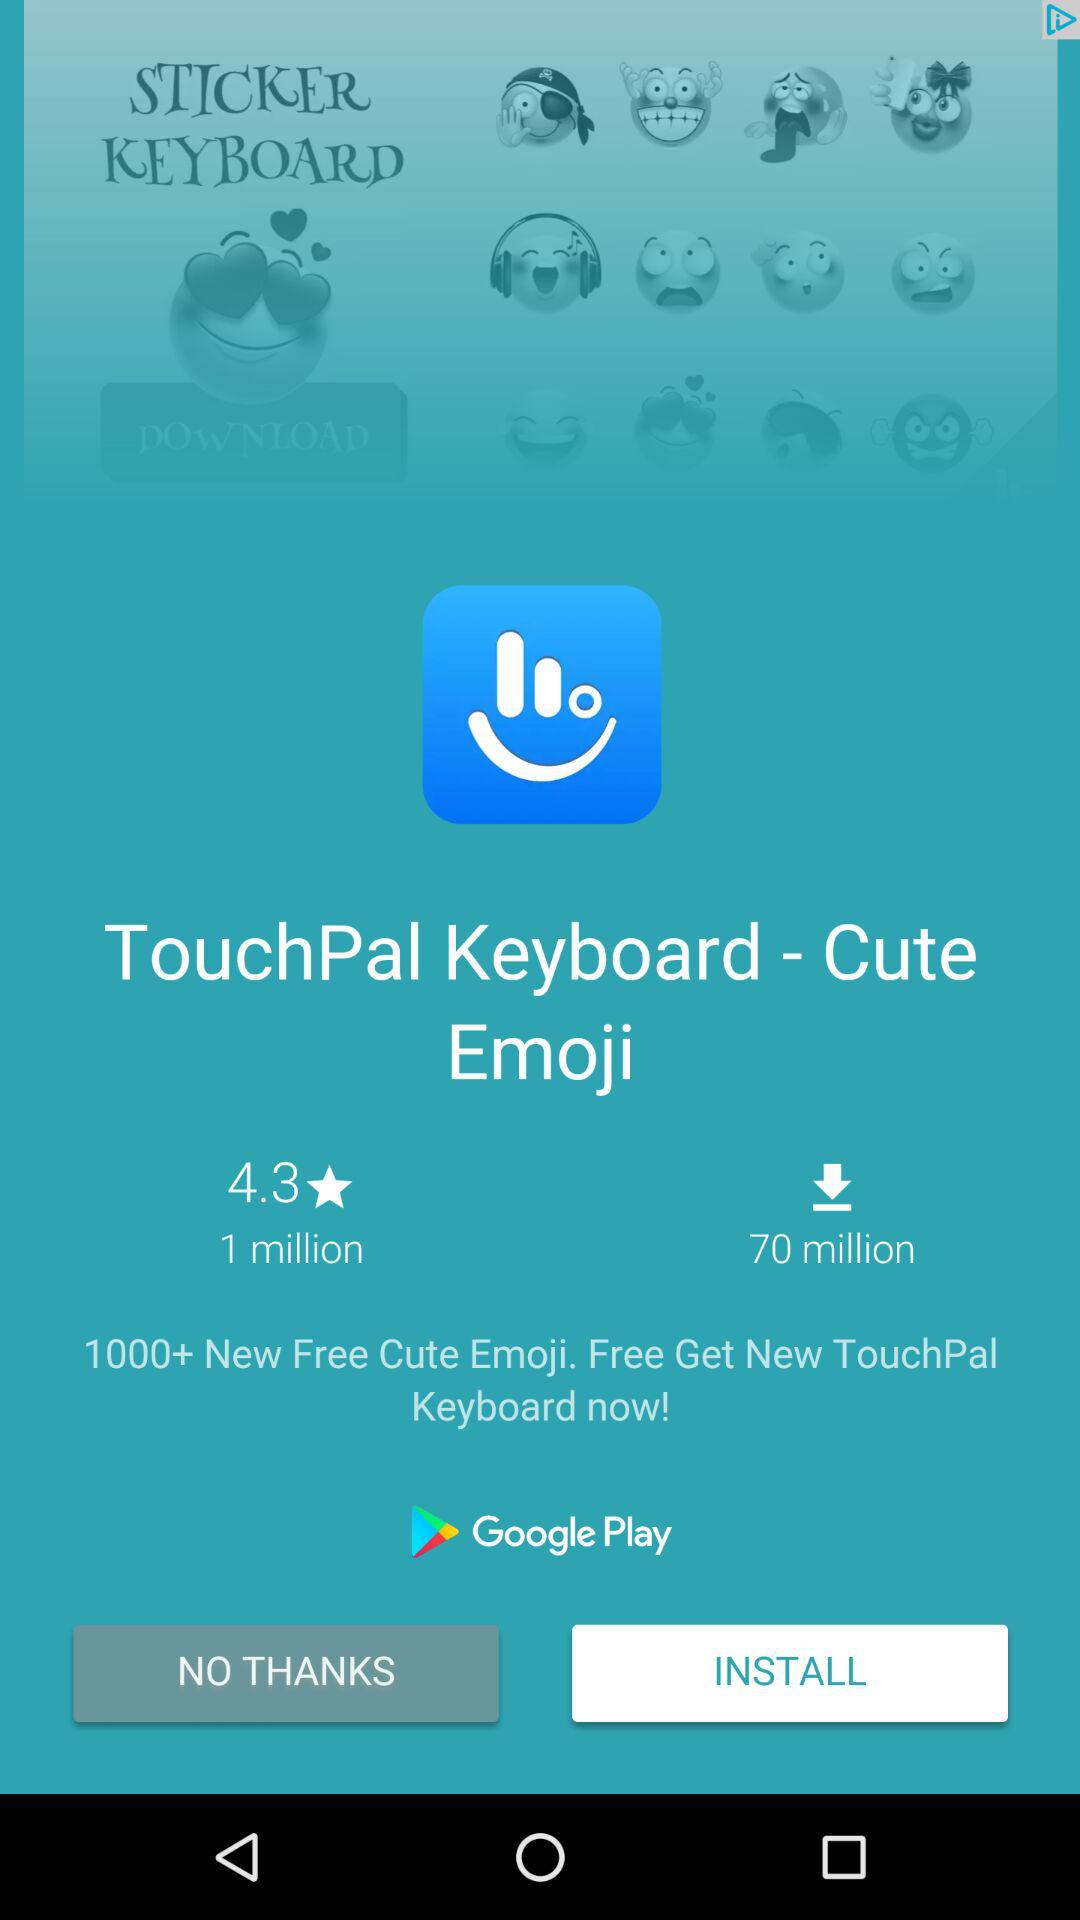How many people have downloaded the application? The number of people who have downloaded the application is 70 million. 